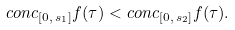Convert formula to latex. <formula><loc_0><loc_0><loc_500><loc_500>c o n c _ { [ 0 , \, s _ { 1 } ] } f ( \tau ) < c o n c _ { [ 0 , \, s _ { 2 } ] } f ( \tau ) .</formula> 